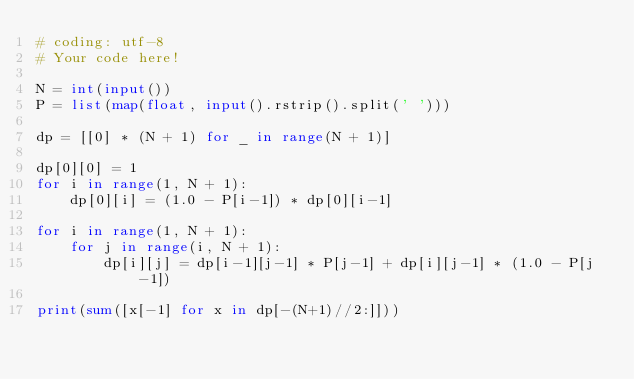Convert code to text. <code><loc_0><loc_0><loc_500><loc_500><_Python_># coding: utf-8
# Your code here!

N = int(input())
P = list(map(float, input().rstrip().split(' ')))

dp = [[0] * (N + 1) for _ in range(N + 1)]

dp[0][0] = 1
for i in range(1, N + 1):
    dp[0][i] = (1.0 - P[i-1]) * dp[0][i-1]
    
for i in range(1, N + 1):
    for j in range(i, N + 1):
        dp[i][j] = dp[i-1][j-1] * P[j-1] + dp[i][j-1] * (1.0 - P[j-1])
        
print(sum([x[-1] for x in dp[-(N+1)//2:]]))
</code> 